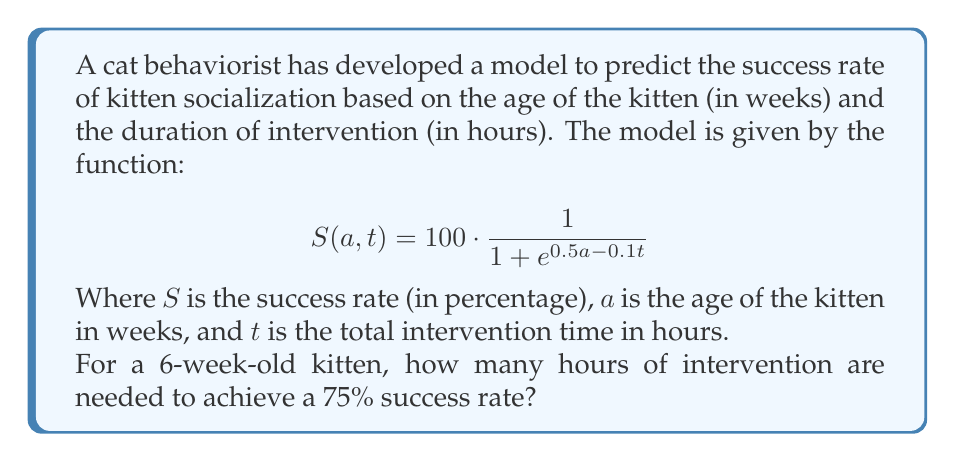Teach me how to tackle this problem. Let's approach this step-by-step:

1) We're given the success rate function:
   $$S(a, t) = 100 \cdot \frac{1}{1 + e^{0.5a - 0.1t}}$$

2) We want to find $t$ when $S = 75$ and $a = 6$. Let's substitute these values:
   $$75 = 100 \cdot \frac{1}{1 + e^{0.5(6) - 0.1t}}$$

3) Simplify the right side:
   $$75 = 100 \cdot \frac{1}{1 + e^{3 - 0.1t}}$$

4) Divide both sides by 100:
   $$0.75 = \frac{1}{1 + e^{3 - 0.1t}}$$

5) Take the reciprocal of both sides:
   $$\frac{4}{3} = 1 + e^{3 - 0.1t}$$

6) Subtract 1 from both sides:
   $$\frac{1}{3} = e^{3 - 0.1t}$$

7) Take the natural log of both sides:
   $$\ln(\frac{1}{3}) = 3 - 0.1t$$

8) Subtract 3 from both sides:
   $$\ln(\frac{1}{3}) - 3 = -0.1t$$

9) Divide both sides by -0.1:
   $$\frac{3 - \ln(\frac{1}{3})}{0.1} = t$$

10) Calculate the final value:
    $$t \approx 41.0986$$

11) Round to the nearest whole number as we're dealing with hours:
    $$t \approx 41 \text{ hours}$$
Answer: 41 hours 